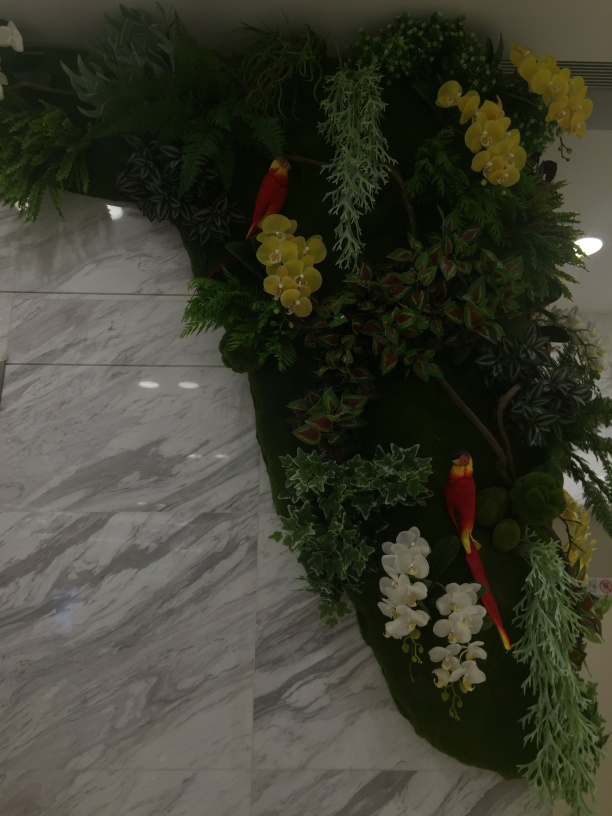What time of day does the lighting in this photo suggest? The lighting in the photo appears to be artificial, lacking natural sunlight, which suggests that it could be taken either in the evening or in a location that does not receive much daylight. The indoor lights cast a soft illumination on the scene, providing enough light to clearly see the detailed arrangement without any harsh shadows. 